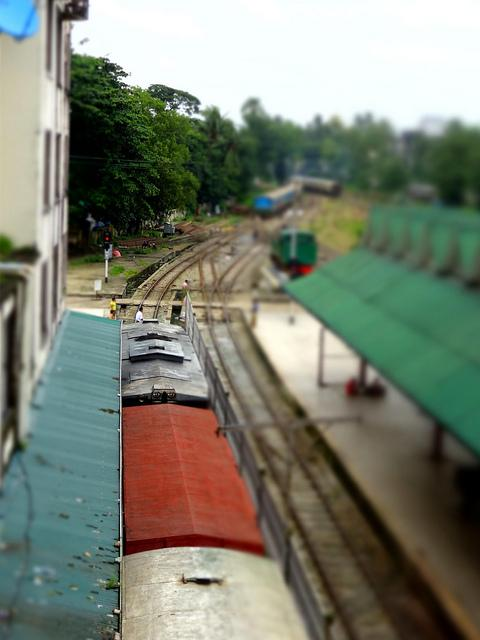Who works at one of these places?

Choices:
A) conductor
B) airline pilot
C) rodeo clown
D) zoo keeper conductor 